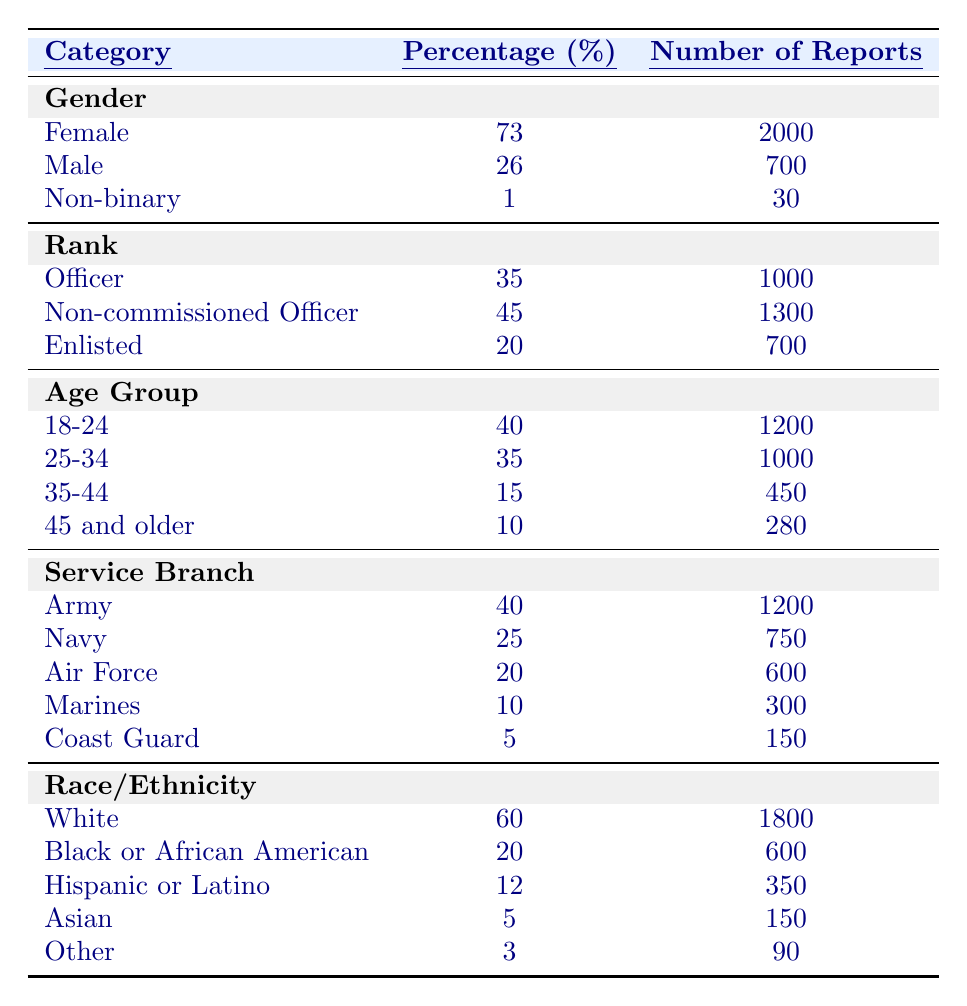What percentage of reports come from females? The table shows that females account for 73% of the reports under the Gender category.
Answer: 73% How many reports were made by enlisted personnel? The data for the rank category indicates that enlisted personnel made 700 reports.
Answer: 700 Is the number of reports from the Army higher than those from the Navy? The Army has 1200 reports, while the Navy has 750; thus, the Army's figures are higher.
Answer: Yes What is the total percentage of reports made by officers and non-commissioned officers combined? Adding the percentages for Officers (35%) and Non-commissioned Officers (45%) gives 35 + 45 = 80%.
Answer: 80% Which age group has the highest number of reports? According to the Age Group data, the 18-24 age group has the highest number of reports at 1200.
Answer: 18-24 Is the percentage of reports made by males higher than that of non-binary individuals? Males make up 26% of the reports, while non-binary individuals account for 1%. Thus, the percentage of males is higher.
Answer: Yes How many more reports were filed by individuals in the 25-34 age group compared to those aged 45 and older? The 25-34 age group has 1000 reports, while the 45 and older group has 280. The difference is 1000 - 280 = 720.
Answer: 720 What proportion of total reports comes from the Coast Guard? The Coast Guard has 150 reports out of a total of 2,980 reports (2000 + 700 + 30 + 1000 + 1300 + 700 + 1200 + 750 + 600 + 300 + 150). The proportion is 150/2980 = 0.0503 or 5%.
Answer: 5% Which race/ethnicity category has the least representation in the reports? The "Other" category has the least representation with only 90 reports.
Answer: Other Considering the given table data, what percentage of the reported incidents come from individuals aged 35 and older? The total reports from the 35-44 age group (450) and those aged 45 and older (280) sum to 450 + 280 = 730 reports. The percentage of total reports is (730/2980) * 100 = 24.5%.
Answer: 24.5% 